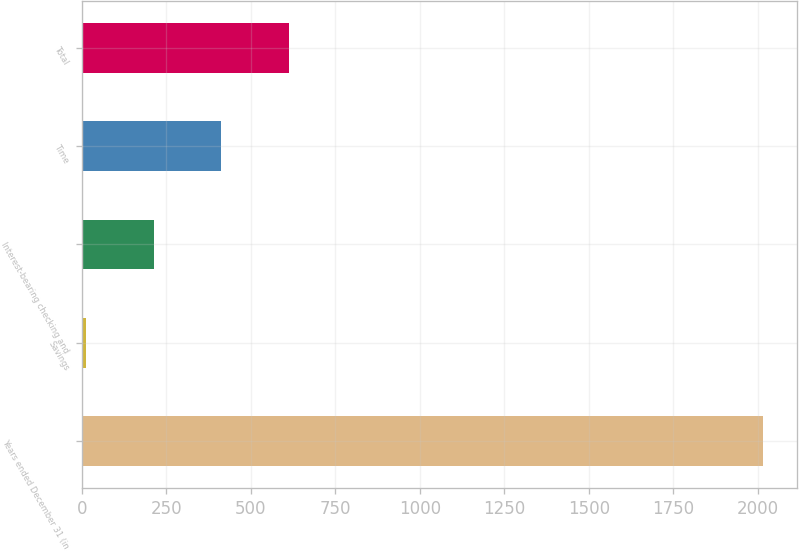Convert chart. <chart><loc_0><loc_0><loc_500><loc_500><bar_chart><fcel>Years ended December 31 (in<fcel>Savings<fcel>Interest-bearing checking and<fcel>Time<fcel>Total<nl><fcel>2015<fcel>11.4<fcel>211.76<fcel>412.12<fcel>612.48<nl></chart> 